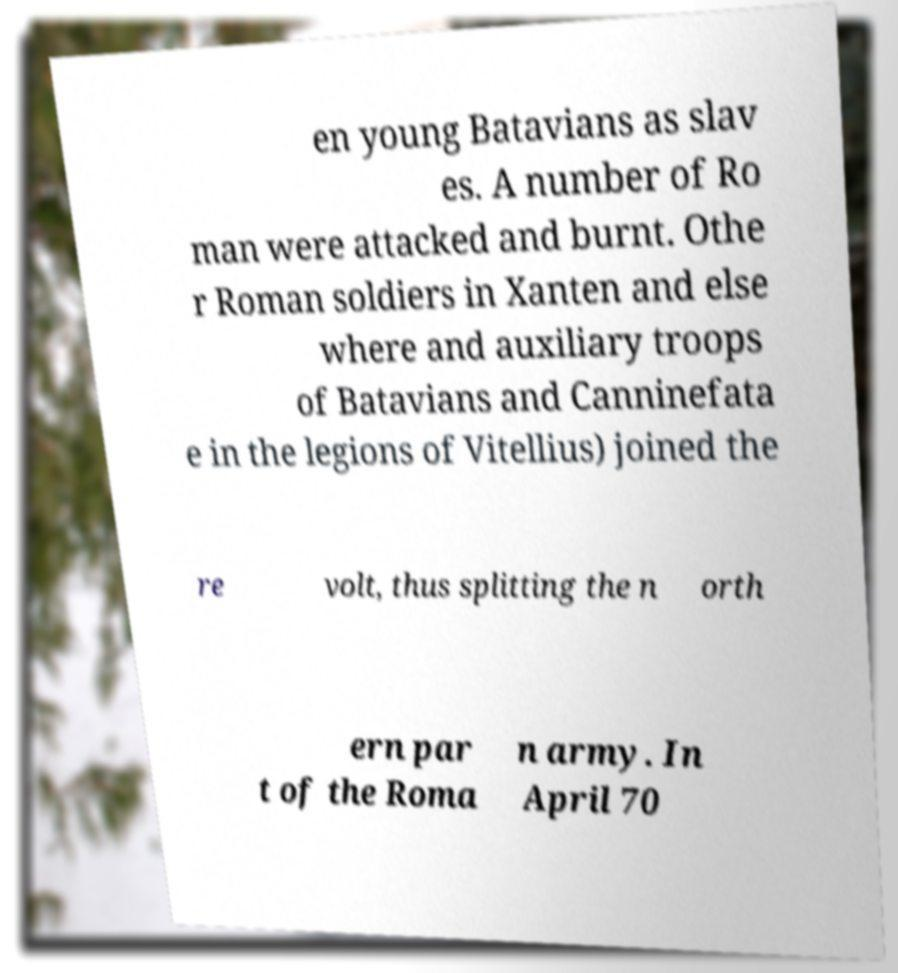What messages or text are displayed in this image? I need them in a readable, typed format. en young Batavians as slav es. A number of Ro man were attacked and burnt. Othe r Roman soldiers in Xanten and else where and auxiliary troops of Batavians and Canninefata e in the legions of Vitellius) joined the re volt, thus splitting the n orth ern par t of the Roma n army. In April 70 